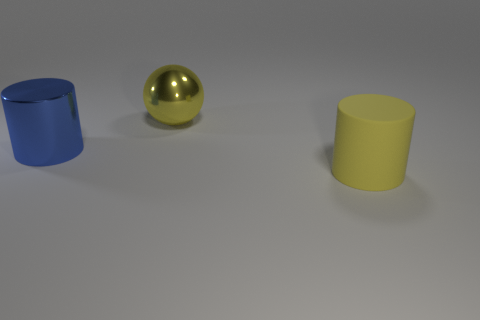There is a big thing that is both behind the rubber thing and in front of the yellow sphere; what is its material?
Ensure brevity in your answer.  Metal. What color is the big thing in front of the big blue object?
Your answer should be compact. Yellow. Are there more large matte cylinders left of the big blue cylinder than big yellow metallic spheres?
Your response must be concise. No. How many other objects are the same size as the blue thing?
Offer a terse response. 2. There is a large rubber cylinder; what number of metallic cylinders are right of it?
Your answer should be compact. 0. Are there the same number of yellow spheres that are on the left side of the big yellow metal ball and big yellow rubber things that are to the left of the large blue metal object?
Your answer should be compact. Yes. What size is the shiny object that is the same shape as the big matte thing?
Provide a short and direct response. Large. The yellow object right of the yellow sphere has what shape?
Your answer should be compact. Cylinder. Is the yellow thing that is on the right side of the yellow shiny ball made of the same material as the cylinder to the left of the big sphere?
Keep it short and to the point. No. The yellow rubber thing has what shape?
Your answer should be very brief. Cylinder. 